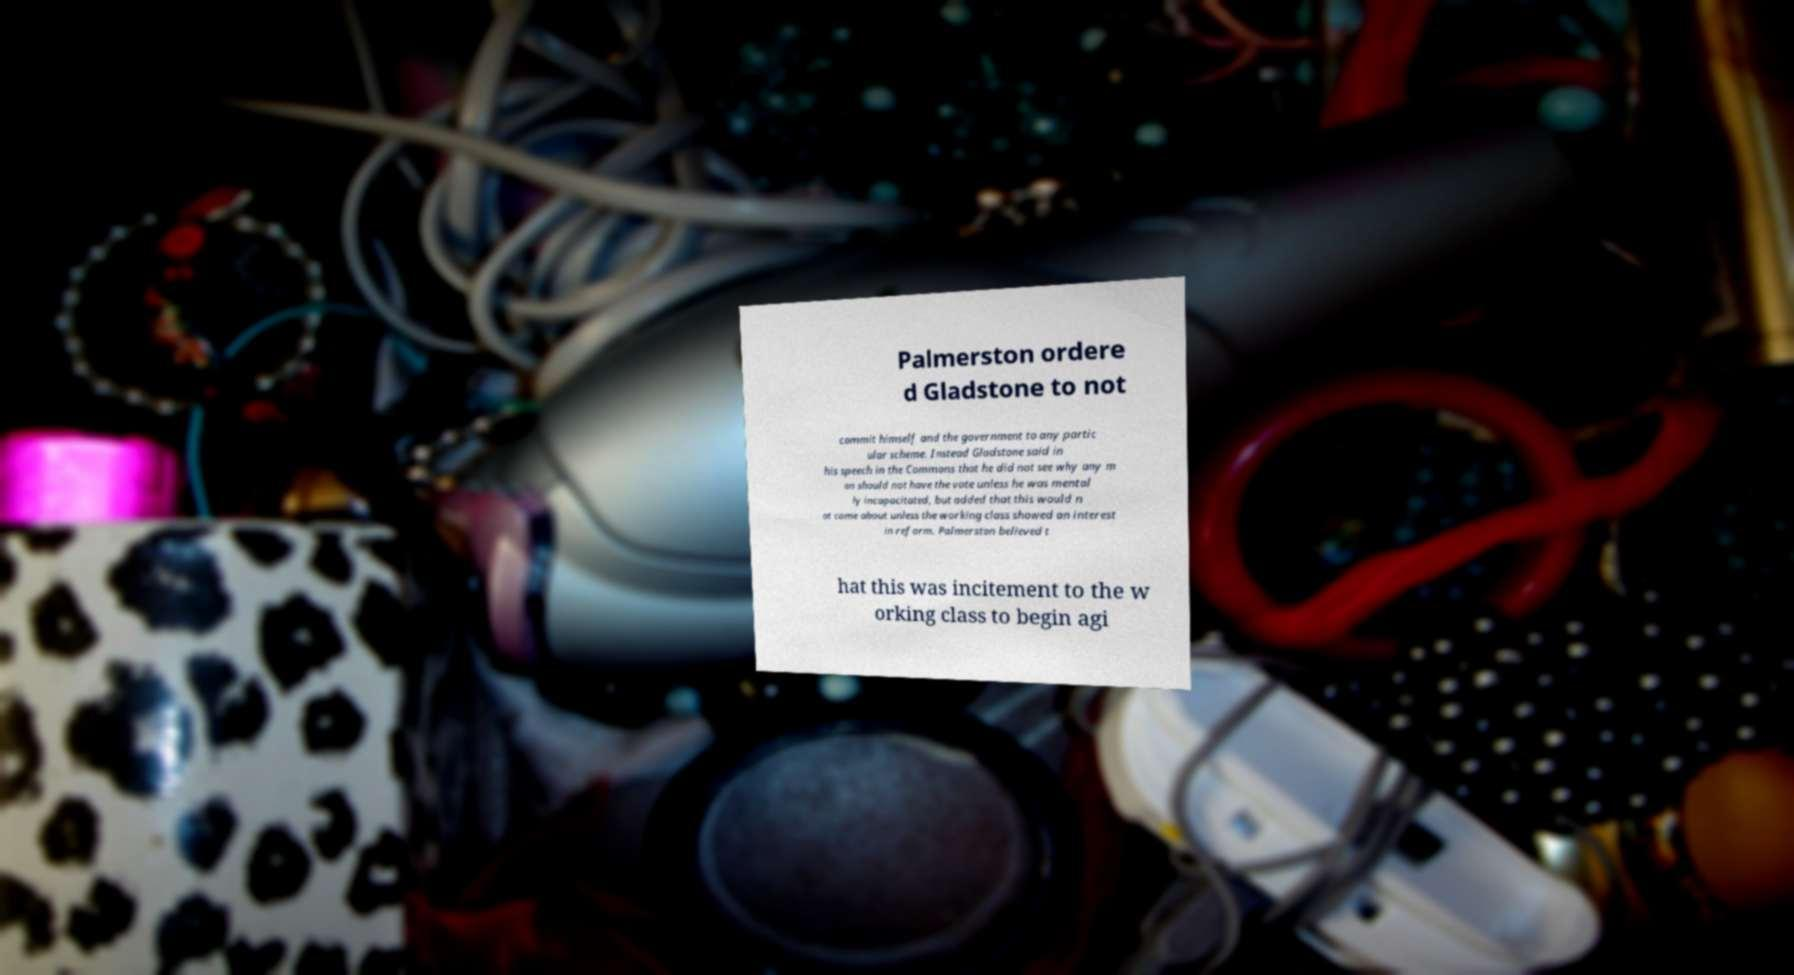What messages or text are displayed in this image? I need them in a readable, typed format. Palmerston ordere d Gladstone to not commit himself and the government to any partic ular scheme. Instead Gladstone said in his speech in the Commons that he did not see why any m an should not have the vote unless he was mental ly incapacitated, but added that this would n ot come about unless the working class showed an interest in reform. Palmerston believed t hat this was incitement to the w orking class to begin agi 